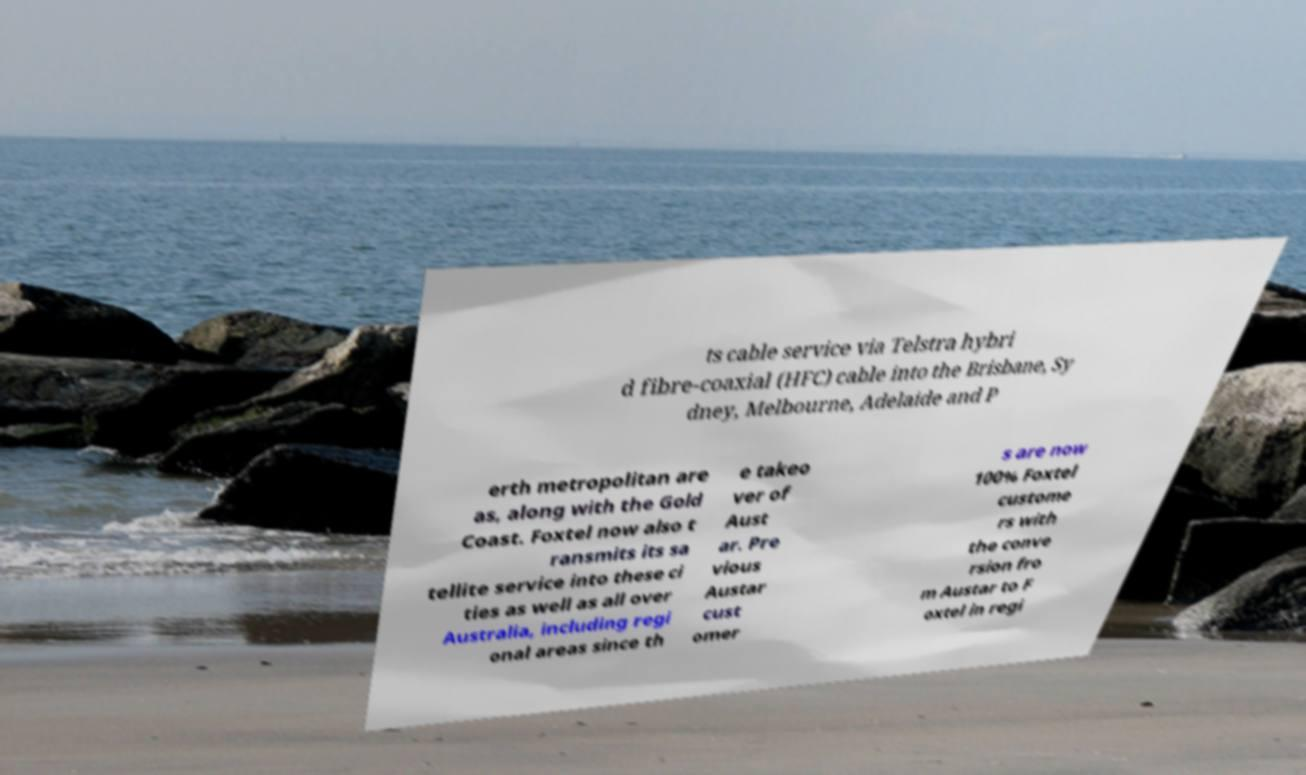Please identify and transcribe the text found in this image. ts cable service via Telstra hybri d fibre-coaxial (HFC) cable into the Brisbane, Sy dney, Melbourne, Adelaide and P erth metropolitan are as, along with the Gold Coast. Foxtel now also t ransmits its sa tellite service into these ci ties as well as all over Australia, including regi onal areas since th e takeo ver of Aust ar. Pre vious Austar cust omer s are now 100% Foxtel custome rs with the conve rsion fro m Austar to F oxtel in regi 